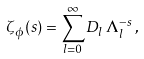<formula> <loc_0><loc_0><loc_500><loc_500>\zeta _ { \phi } ( s ) = \sum ^ { \infty } _ { l = 0 } D _ { l } \, \Lambda _ { l } ^ { - s } \, ,</formula> 